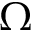<formula> <loc_0><loc_0><loc_500><loc_500>\Omega</formula> 